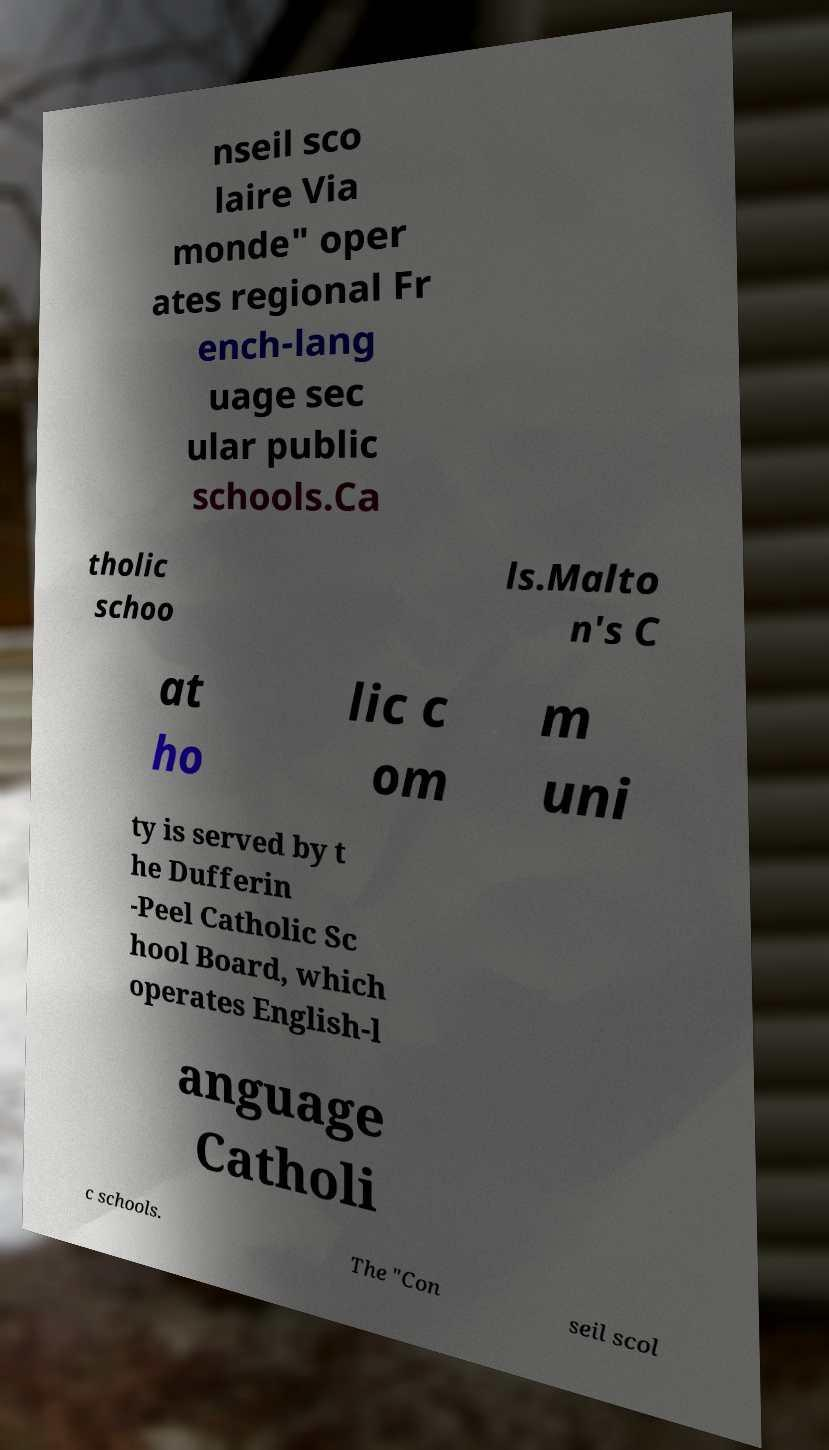There's text embedded in this image that I need extracted. Can you transcribe it verbatim? nseil sco laire Via monde" oper ates regional Fr ench-lang uage sec ular public schools.Ca tholic schoo ls.Malto n's C at ho lic c om m uni ty is served by t he Dufferin -Peel Catholic Sc hool Board, which operates English-l anguage Catholi c schools. The "Con seil scol 